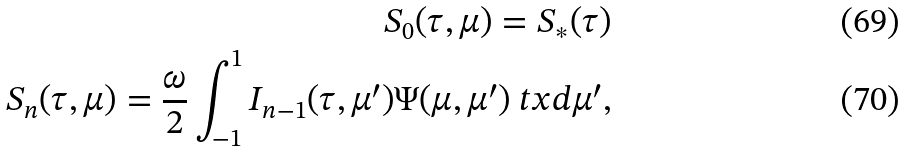Convert formula to latex. <formula><loc_0><loc_0><loc_500><loc_500>S _ { 0 } ( \tau , \mu ) = S _ { * } ( \tau ) \\ S _ { n } ( \tau , \mu ) = \frac { \omega } { 2 } \int _ { - 1 } ^ { 1 } I _ { n - 1 } ( \tau , \mu ^ { \prime } ) \Psi ( \mu , \mu ^ { \prime } ) \ t x d \mu ^ { \prime } ,</formula> 